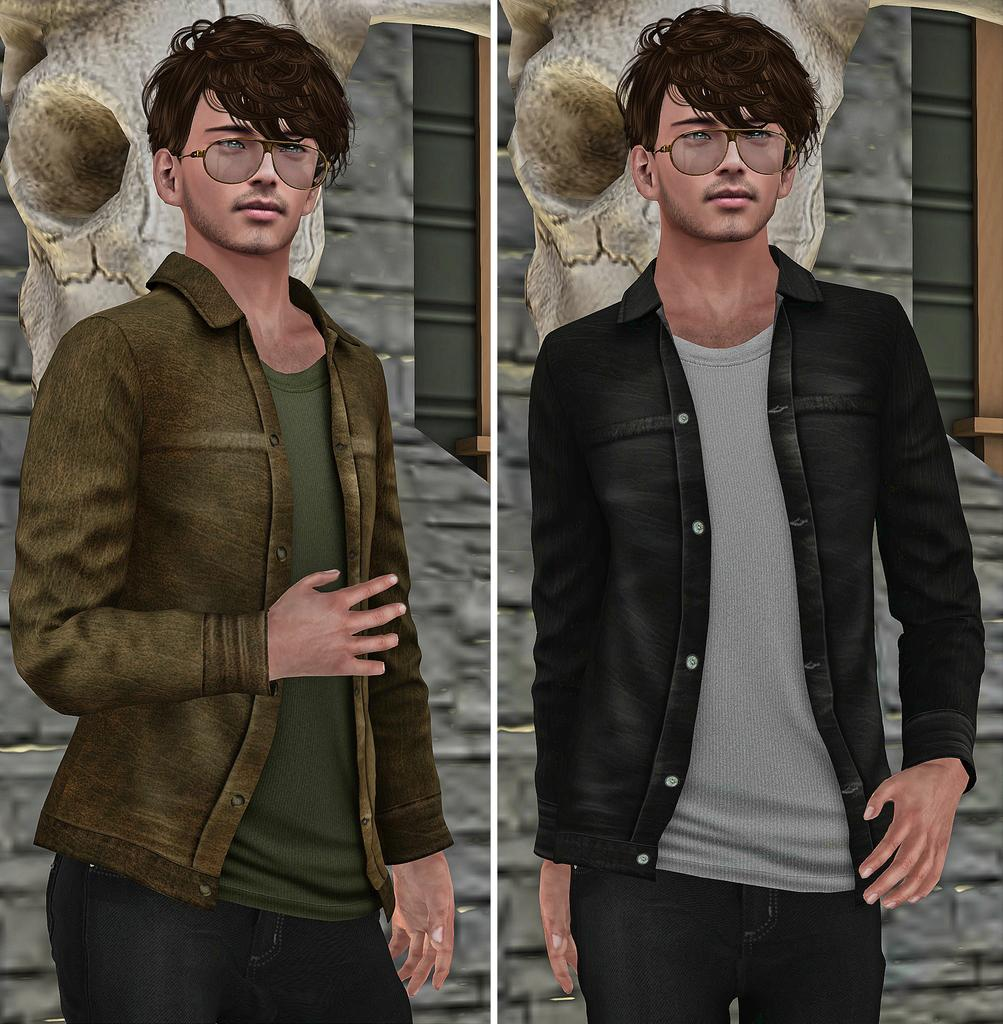What type of image is being described? The image is animated and a collage of two images. Are the two images in the collage similar or different? Both images in the collage are the same. What can be seen in the background of the image? There is a wall in the background of the image. Who or what is in the middle of the image? A man is standing in the middle of the image. What type of potato is being used in the battle depicted in the image? There is no battle or potato present in the image; it features an animated collage of two similar images with a man standing in the middle and a wall in the background. 